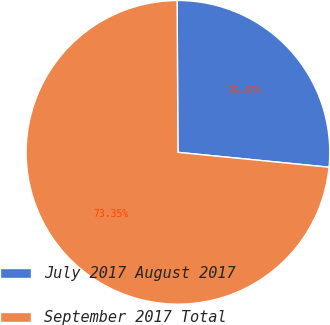Convert chart to OTSL. <chart><loc_0><loc_0><loc_500><loc_500><pie_chart><fcel>July 2017 August 2017<fcel>September 2017 Total<nl><fcel>26.65%<fcel>73.35%<nl></chart> 